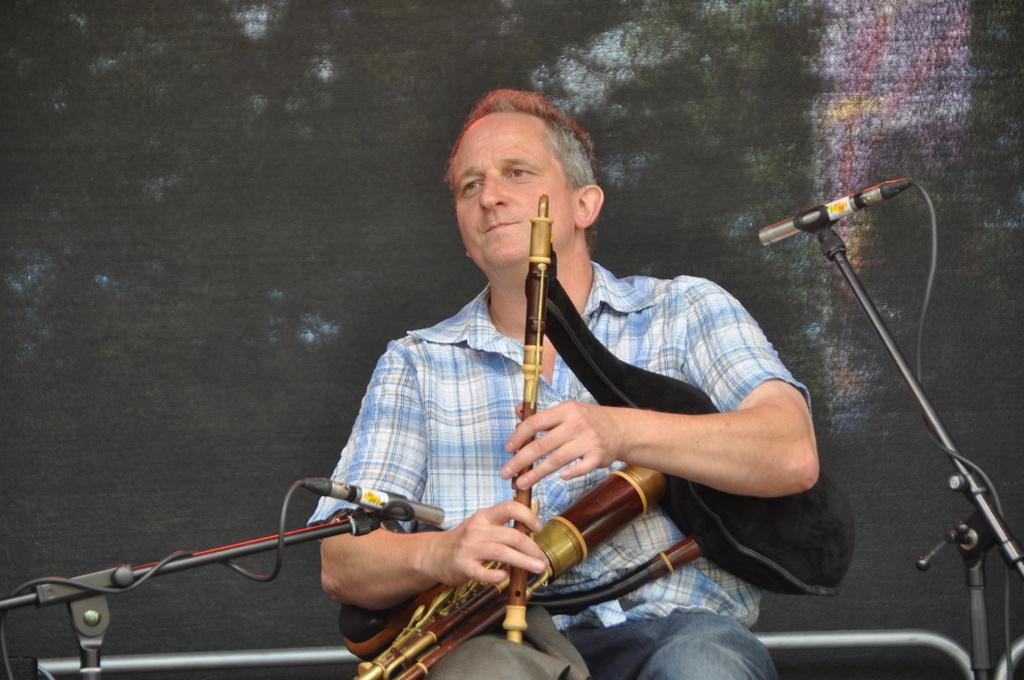Describe this image in one or two sentences. In the image there is a man sitting and holding musical instruments in his hands. And also there are stands with mics. Behind the man there is a wall with painting. 